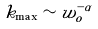<formula> <loc_0><loc_0><loc_500><loc_500>k _ { \max } \sim w _ { o } ^ { - \alpha }</formula> 